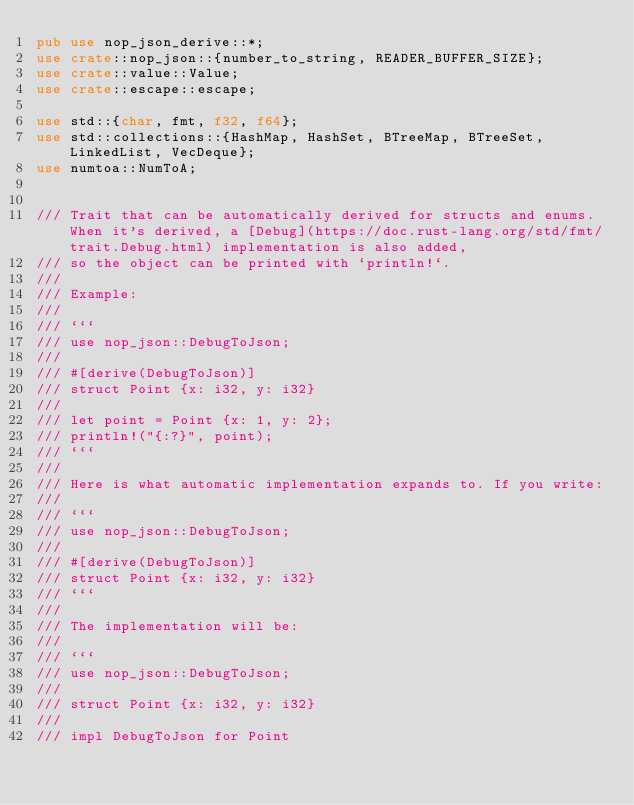Convert code to text. <code><loc_0><loc_0><loc_500><loc_500><_Rust_>pub use nop_json_derive::*;
use crate::nop_json::{number_to_string, READER_BUFFER_SIZE};
use crate::value::Value;
use crate::escape::escape;

use std::{char, fmt, f32, f64};
use std::collections::{HashMap, HashSet, BTreeMap, BTreeSet, LinkedList, VecDeque};
use numtoa::NumToA;


/// Trait that can be automatically derived for structs and enums. When it's derived, a [Debug](https://doc.rust-lang.org/std/fmt/trait.Debug.html) implementation is also added,
/// so the object can be printed with `println!`.
///
/// Example:
///
/// ```
/// use nop_json::DebugToJson;
///
/// #[derive(DebugToJson)]
/// struct Point {x: i32, y: i32}
///
/// let point = Point {x: 1, y: 2};
/// println!("{:?}", point);
/// ```
///
/// Here is what automatic implementation expands to. If you write:
///
/// ```
/// use nop_json::DebugToJson;
///
/// #[derive(DebugToJson)]
/// struct Point {x: i32, y: i32}
/// ```
///
/// The implementation will be:
///
/// ```
/// use nop_json::DebugToJson;
///
/// struct Point {x: i32, y: i32}
///
/// impl DebugToJson for Point</code> 